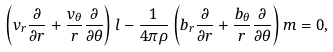<formula> <loc_0><loc_0><loc_500><loc_500>\left ( v _ { r } \frac { \partial } { \partial r } + \frac { v _ { \theta } } { r } \frac { \partial } { \partial \theta } \right ) l - \frac { 1 } { 4 \pi \rho } \left ( b _ { r } \frac { \partial } { \partial r } + \frac { b _ { \theta } } { r } \frac { \partial } { \partial \theta } \right ) m = 0 ,</formula> 